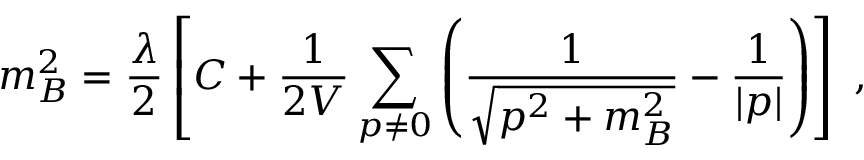<formula> <loc_0><loc_0><loc_500><loc_500>m _ { B } ^ { 2 } = { \frac { \lambda } { 2 } } \left [ C + { \frac { 1 } { 2 V } } \sum _ { p \neq 0 } \left ( \frac { 1 } { \sqrt { { p } ^ { 2 } + m _ { B } ^ { 2 } } } - \frac { 1 } { | p | } \right ) \right ] ,</formula> 